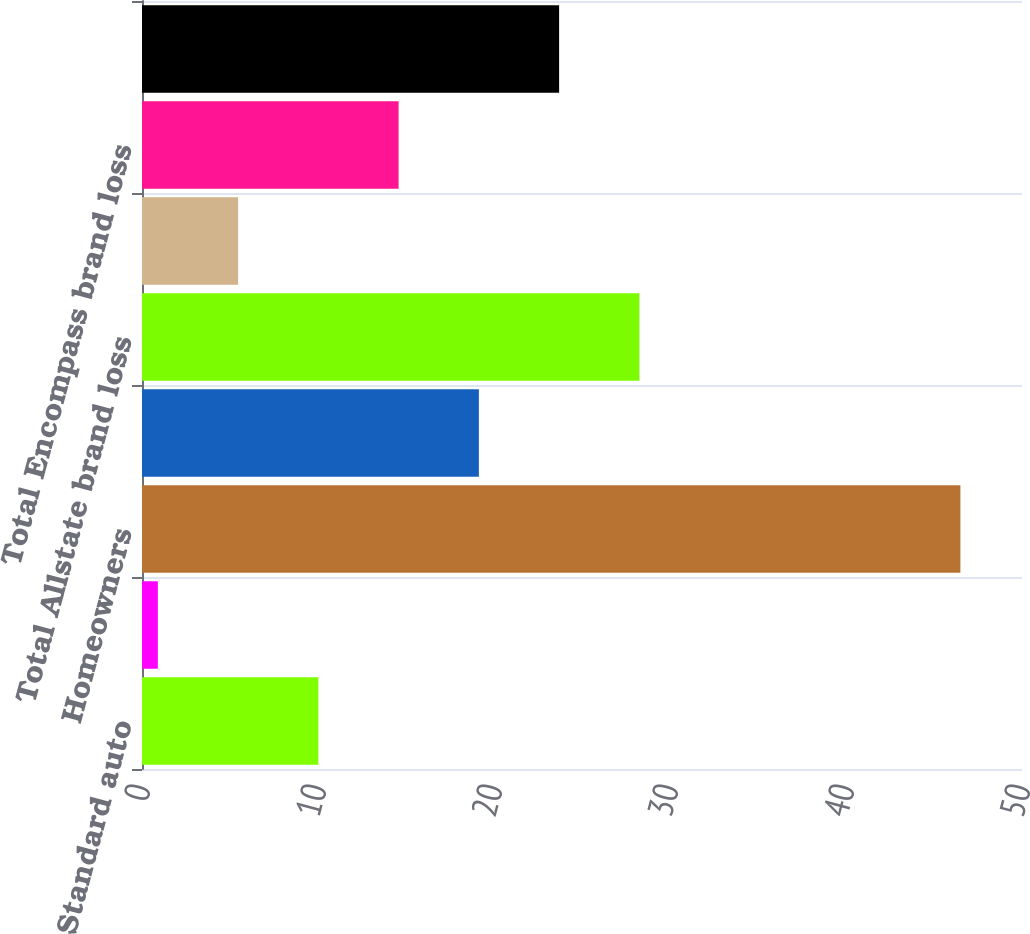Convert chart. <chart><loc_0><loc_0><loc_500><loc_500><bar_chart><fcel>Standard auto<fcel>Non-standard auto<fcel>Homeowners<fcel>Other personal lines<fcel>Total Allstate brand loss<fcel>Standard auto (1)<fcel>Total Encompass brand loss<fcel>Allstate Protection loss ratio<nl><fcel>10.02<fcel>0.9<fcel>46.5<fcel>19.14<fcel>28.26<fcel>5.46<fcel>14.58<fcel>23.7<nl></chart> 